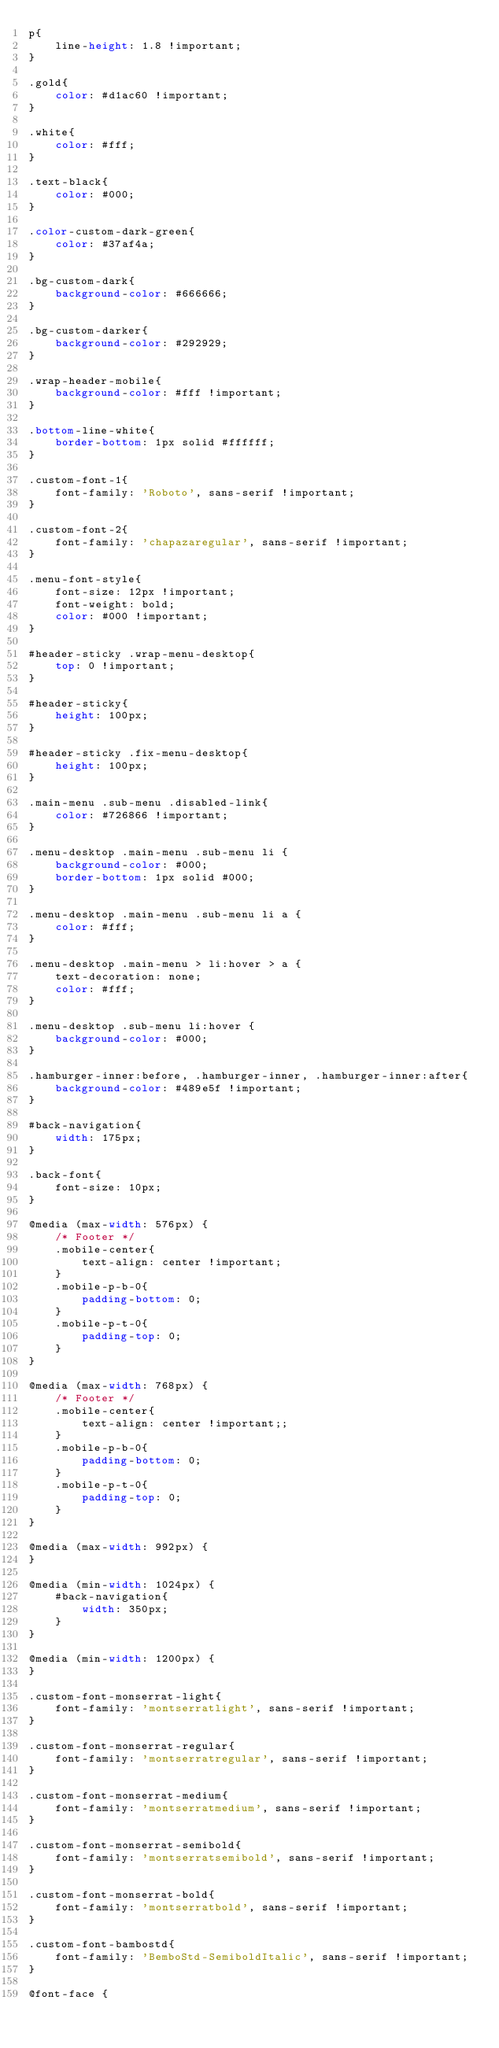<code> <loc_0><loc_0><loc_500><loc_500><_CSS_>p{
    line-height: 1.8 !important;
}

.gold{
    color: #d1ac60 !important;
}

.white{
    color: #fff;
}

.text-black{
    color: #000;
}

.color-custom-dark-green{
    color: #37af4a;
}

.bg-custom-dark{
    background-color: #666666;
}

.bg-custom-darker{
    background-color: #292929;
}

.wrap-header-mobile{
    background-color: #fff !important;
}

.bottom-line-white{
    border-bottom: 1px solid #ffffff;
}

.custom-font-1{
    font-family: 'Roboto', sans-serif !important;
}

.custom-font-2{
    font-family: 'chapazaregular', sans-serif !important;
}

.menu-font-style{
    font-size: 12px !important;
    font-weight: bold;
    color: #000 !important;
}

#header-sticky .wrap-menu-desktop{
    top: 0 !important;
}

#header-sticky{
    height: 100px;
}

#header-sticky .fix-menu-desktop{
    height: 100px;
}

.main-menu .sub-menu .disabled-link{
    color: #726866 !important;
}

.menu-desktop .main-menu .sub-menu li {
    background-color: #000;
    border-bottom: 1px solid #000;
}

.menu-desktop .main-menu .sub-menu li a {
    color: #fff;
}

.menu-desktop .main-menu > li:hover > a {
    text-decoration: none;
    color: #fff;
}

.menu-desktop .sub-menu li:hover {
    background-color: #000;
}

.hamburger-inner:before, .hamburger-inner, .hamburger-inner:after{
    background-color: #489e5f !important;
}

#back-navigation{
    width: 175px;
}

.back-font{
    font-size: 10px;
}

@media (max-width: 576px) {
    /* Footer */
    .mobile-center{
        text-align: center !important;
    }
    .mobile-p-b-0{
        padding-bottom: 0;
    }
    .mobile-p-t-0{
        padding-top: 0;
    }
}

@media (max-width: 768px) {
    /* Footer */
    .mobile-center{
        text-align: center !important;;
    }
    .mobile-p-b-0{
        padding-bottom: 0;
    }
    .mobile-p-t-0{
        padding-top: 0;
    }
}

@media (max-width: 992px) {
}

@media (min-width: 1024px) {
    #back-navigation{
        width: 350px;
    }
}

@media (min-width: 1200px) {
}

.custom-font-monserrat-light{
    font-family: 'montserratlight', sans-serif !important;
}

.custom-font-monserrat-regular{
    font-family: 'montserratregular', sans-serif !important;
}

.custom-font-monserrat-medium{
    font-family: 'montserratmedium', sans-serif !important;
}

.custom-font-monserrat-semibold{
    font-family: 'montserratsemibold', sans-serif !important;
}

.custom-font-monserrat-bold{
    font-family: 'montserratbold', sans-serif !important;
}

.custom-font-bambostd{
    font-family: 'BemboStd-SemiboldItalic', sans-serif !important;
}

@font-face {</code> 